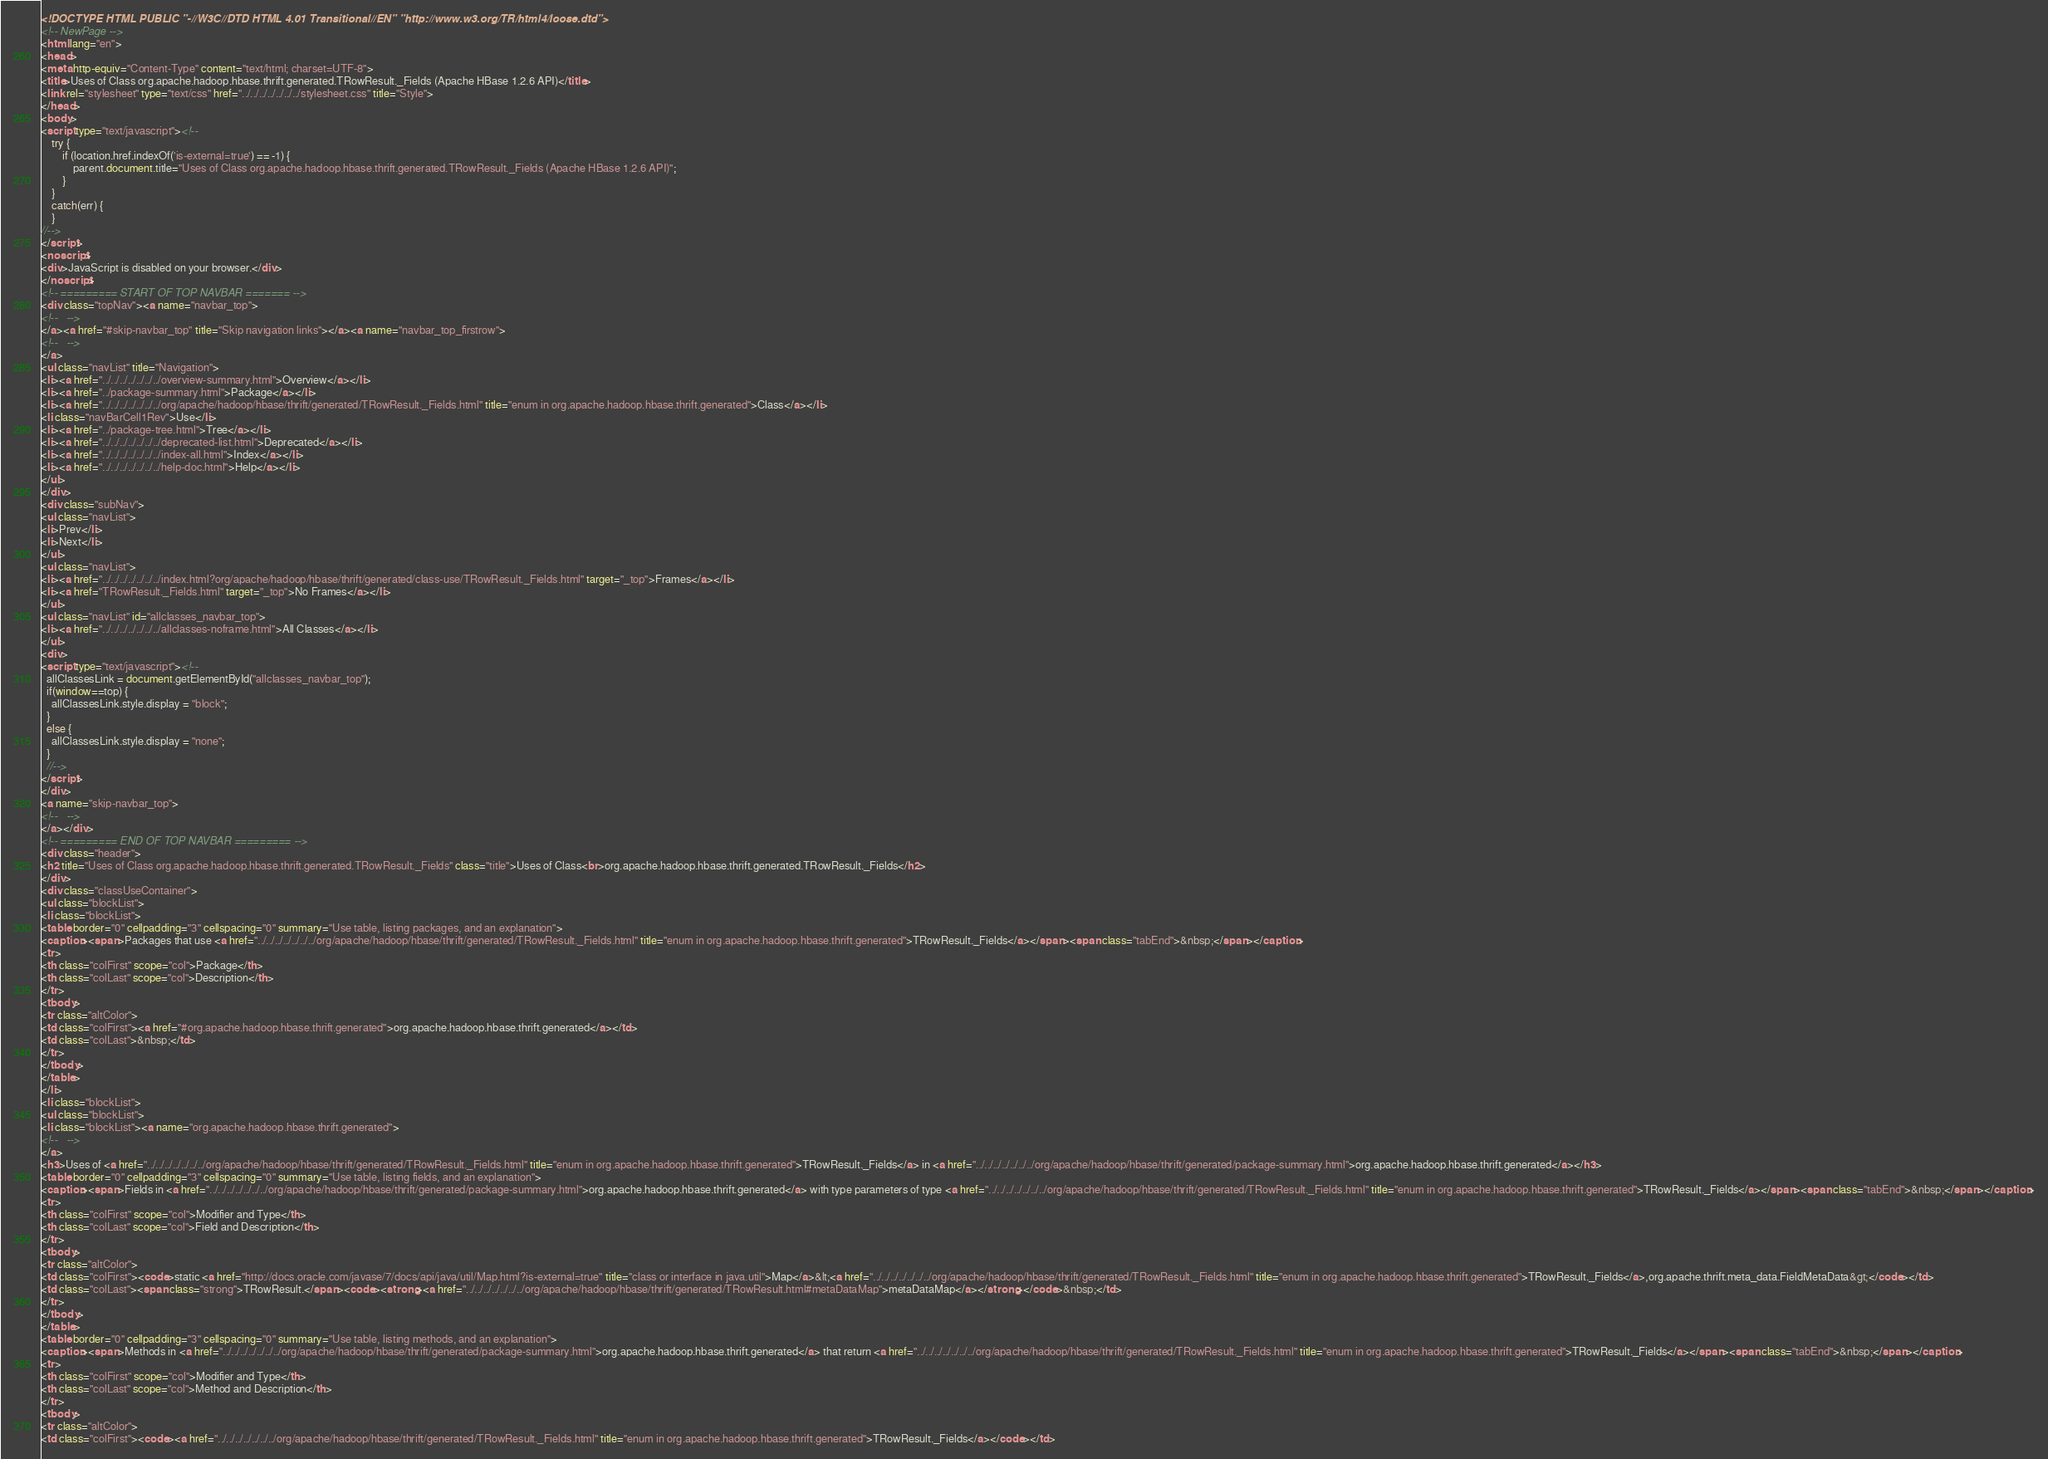<code> <loc_0><loc_0><loc_500><loc_500><_HTML_><!DOCTYPE HTML PUBLIC "-//W3C//DTD HTML 4.01 Transitional//EN" "http://www.w3.org/TR/html4/loose.dtd">
<!-- NewPage -->
<html lang="en">
<head>
<meta http-equiv="Content-Type" content="text/html; charset=UTF-8">
<title>Uses of Class org.apache.hadoop.hbase.thrift.generated.TRowResult._Fields (Apache HBase 1.2.6 API)</title>
<link rel="stylesheet" type="text/css" href="../../../../../../../stylesheet.css" title="Style">
</head>
<body>
<script type="text/javascript"><!--
    try {
        if (location.href.indexOf('is-external=true') == -1) {
            parent.document.title="Uses of Class org.apache.hadoop.hbase.thrift.generated.TRowResult._Fields (Apache HBase 1.2.6 API)";
        }
    }
    catch(err) {
    }
//-->
</script>
<noscript>
<div>JavaScript is disabled on your browser.</div>
</noscript>
<!-- ========= START OF TOP NAVBAR ======= -->
<div class="topNav"><a name="navbar_top">
<!--   -->
</a><a href="#skip-navbar_top" title="Skip navigation links"></a><a name="navbar_top_firstrow">
<!--   -->
</a>
<ul class="navList" title="Navigation">
<li><a href="../../../../../../../overview-summary.html">Overview</a></li>
<li><a href="../package-summary.html">Package</a></li>
<li><a href="../../../../../../../org/apache/hadoop/hbase/thrift/generated/TRowResult._Fields.html" title="enum in org.apache.hadoop.hbase.thrift.generated">Class</a></li>
<li class="navBarCell1Rev">Use</li>
<li><a href="../package-tree.html">Tree</a></li>
<li><a href="../../../../../../../deprecated-list.html">Deprecated</a></li>
<li><a href="../../../../../../../index-all.html">Index</a></li>
<li><a href="../../../../../../../help-doc.html">Help</a></li>
</ul>
</div>
<div class="subNav">
<ul class="navList">
<li>Prev</li>
<li>Next</li>
</ul>
<ul class="navList">
<li><a href="../../../../../../../index.html?org/apache/hadoop/hbase/thrift/generated/class-use/TRowResult._Fields.html" target="_top">Frames</a></li>
<li><a href="TRowResult._Fields.html" target="_top">No Frames</a></li>
</ul>
<ul class="navList" id="allclasses_navbar_top">
<li><a href="../../../../../../../allclasses-noframe.html">All Classes</a></li>
</ul>
<div>
<script type="text/javascript"><!--
  allClassesLink = document.getElementById("allclasses_navbar_top");
  if(window==top) {
    allClassesLink.style.display = "block";
  }
  else {
    allClassesLink.style.display = "none";
  }
  //-->
</script>
</div>
<a name="skip-navbar_top">
<!--   -->
</a></div>
<!-- ========= END OF TOP NAVBAR ========= -->
<div class="header">
<h2 title="Uses of Class org.apache.hadoop.hbase.thrift.generated.TRowResult._Fields" class="title">Uses of Class<br>org.apache.hadoop.hbase.thrift.generated.TRowResult._Fields</h2>
</div>
<div class="classUseContainer">
<ul class="blockList">
<li class="blockList">
<table border="0" cellpadding="3" cellspacing="0" summary="Use table, listing packages, and an explanation">
<caption><span>Packages that use <a href="../../../../../../../org/apache/hadoop/hbase/thrift/generated/TRowResult._Fields.html" title="enum in org.apache.hadoop.hbase.thrift.generated">TRowResult._Fields</a></span><span class="tabEnd">&nbsp;</span></caption>
<tr>
<th class="colFirst" scope="col">Package</th>
<th class="colLast" scope="col">Description</th>
</tr>
<tbody>
<tr class="altColor">
<td class="colFirst"><a href="#org.apache.hadoop.hbase.thrift.generated">org.apache.hadoop.hbase.thrift.generated</a></td>
<td class="colLast">&nbsp;</td>
</tr>
</tbody>
</table>
</li>
<li class="blockList">
<ul class="blockList">
<li class="blockList"><a name="org.apache.hadoop.hbase.thrift.generated">
<!--   -->
</a>
<h3>Uses of <a href="../../../../../../../org/apache/hadoop/hbase/thrift/generated/TRowResult._Fields.html" title="enum in org.apache.hadoop.hbase.thrift.generated">TRowResult._Fields</a> in <a href="../../../../../../../org/apache/hadoop/hbase/thrift/generated/package-summary.html">org.apache.hadoop.hbase.thrift.generated</a></h3>
<table border="0" cellpadding="3" cellspacing="0" summary="Use table, listing fields, and an explanation">
<caption><span>Fields in <a href="../../../../../../../org/apache/hadoop/hbase/thrift/generated/package-summary.html">org.apache.hadoop.hbase.thrift.generated</a> with type parameters of type <a href="../../../../../../../org/apache/hadoop/hbase/thrift/generated/TRowResult._Fields.html" title="enum in org.apache.hadoop.hbase.thrift.generated">TRowResult._Fields</a></span><span class="tabEnd">&nbsp;</span></caption>
<tr>
<th class="colFirst" scope="col">Modifier and Type</th>
<th class="colLast" scope="col">Field and Description</th>
</tr>
<tbody>
<tr class="altColor">
<td class="colFirst"><code>static <a href="http://docs.oracle.com/javase/7/docs/api/java/util/Map.html?is-external=true" title="class or interface in java.util">Map</a>&lt;<a href="../../../../../../../org/apache/hadoop/hbase/thrift/generated/TRowResult._Fields.html" title="enum in org.apache.hadoop.hbase.thrift.generated">TRowResult._Fields</a>,org.apache.thrift.meta_data.FieldMetaData&gt;</code></td>
<td class="colLast"><span class="strong">TRowResult.</span><code><strong><a href="../../../../../../../org/apache/hadoop/hbase/thrift/generated/TRowResult.html#metaDataMap">metaDataMap</a></strong></code>&nbsp;</td>
</tr>
</tbody>
</table>
<table border="0" cellpadding="3" cellspacing="0" summary="Use table, listing methods, and an explanation">
<caption><span>Methods in <a href="../../../../../../../org/apache/hadoop/hbase/thrift/generated/package-summary.html">org.apache.hadoop.hbase.thrift.generated</a> that return <a href="../../../../../../../org/apache/hadoop/hbase/thrift/generated/TRowResult._Fields.html" title="enum in org.apache.hadoop.hbase.thrift.generated">TRowResult._Fields</a></span><span class="tabEnd">&nbsp;</span></caption>
<tr>
<th class="colFirst" scope="col">Modifier and Type</th>
<th class="colLast" scope="col">Method and Description</th>
</tr>
<tbody>
<tr class="altColor">
<td class="colFirst"><code><a href="../../../../../../../org/apache/hadoop/hbase/thrift/generated/TRowResult._Fields.html" title="enum in org.apache.hadoop.hbase.thrift.generated">TRowResult._Fields</a></code></td></code> 